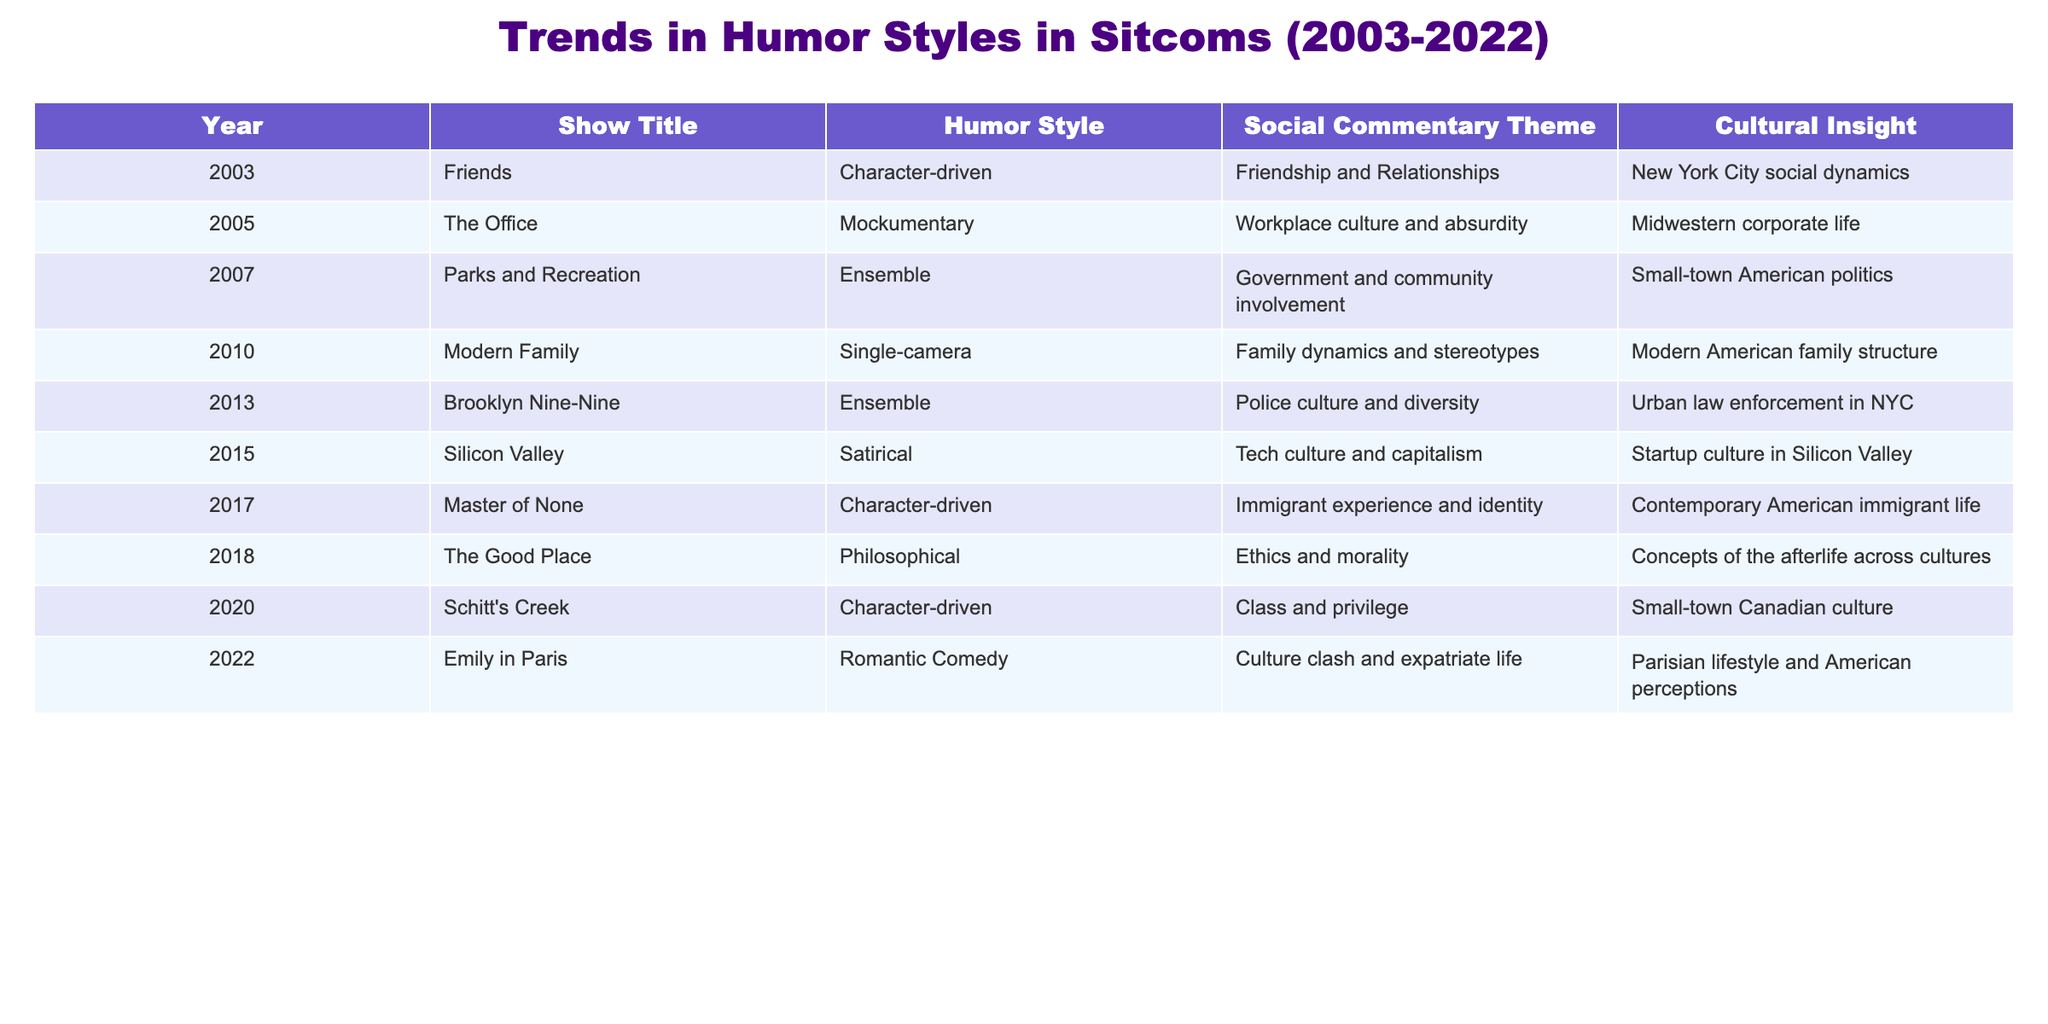What humor style was used in "Brooklyn Nine-Nine"? The table indicates the humor style of "Brooklyn Nine-Nine" is categorized as "Ensemble." This is directly retrieved from the humor style column corresponding to that show.
Answer: Ensemble Which show from 2010 focuses on family dynamics and stereotypes? According to the table, "Modern Family" from 2010 addresses family dynamics and stereotypes as its social commentary theme. This is clearly stated in the corresponding row for that year.
Answer: Modern Family What years had shows that used a character-driven humor style? The table lists the shows with a character-driven humor style as "Friends" (2003), "Master of None" (2017), and "Schitt's Creek" (2020). To find the years, I can simply refer to the first column corresponding to those shows.
Answer: 2003, 2017, 2020 Are there more shows with a satirical humor style or a philosophical humor style in the table? The table has one show with a satirical style ("Silicon Valley" in 2015) and one show with a philosophical style ("The Good Place" in 2018). To compare, we can count them: one of each means they are equal.
Answer: Equal Which social commentary themes are represented by ensemble humor styles? The shows categorized under ensemble humor styles are "Parks and Recreation" and "Brooklyn Nine-Nine." Their social commentary themes are "Government and community involvement" and "Police culture and diversity," respectively. I simply found the rows for these shows and extracted their themes.
Answer: Government and community involvement, Police culture and diversity What is the cultural insight of the show "Emily in Paris"? The cultural insight listed for "Emily in Paris" is "Parisian lifestyle and American perceptions." This information is found in the cultural insight column of the corresponding row from the table.
Answer: Parisian lifestyle and American perceptions Which show from the last two years has a romantic comedy humor style? The table states that "Emily in Paris," from 2022, features a romantic comedy humor style. I looked at the last two years in the table and found this specific humor style associated with the show.
Answer: Emily in Paris How many shows address cultural insights related to American life? The table shows that the following shows provide insights related to American life: "Friends," "The Office," "Parks and Recreation," "Modern Family," "Brooklyn Nine-Nine," and "Master of None." Counting these gives us six shows addressing American cultural insights.
Answer: 6 What social commentary theme is unique to "Silicon Valley"? The social commentary theme unique to "Silicon Valley" is "Tech culture and capitalism." This can be identified in the specific entry for "Silicon Valley" in the table, as no other shows have this exact theme.
Answer: Tech culture and capitalism 